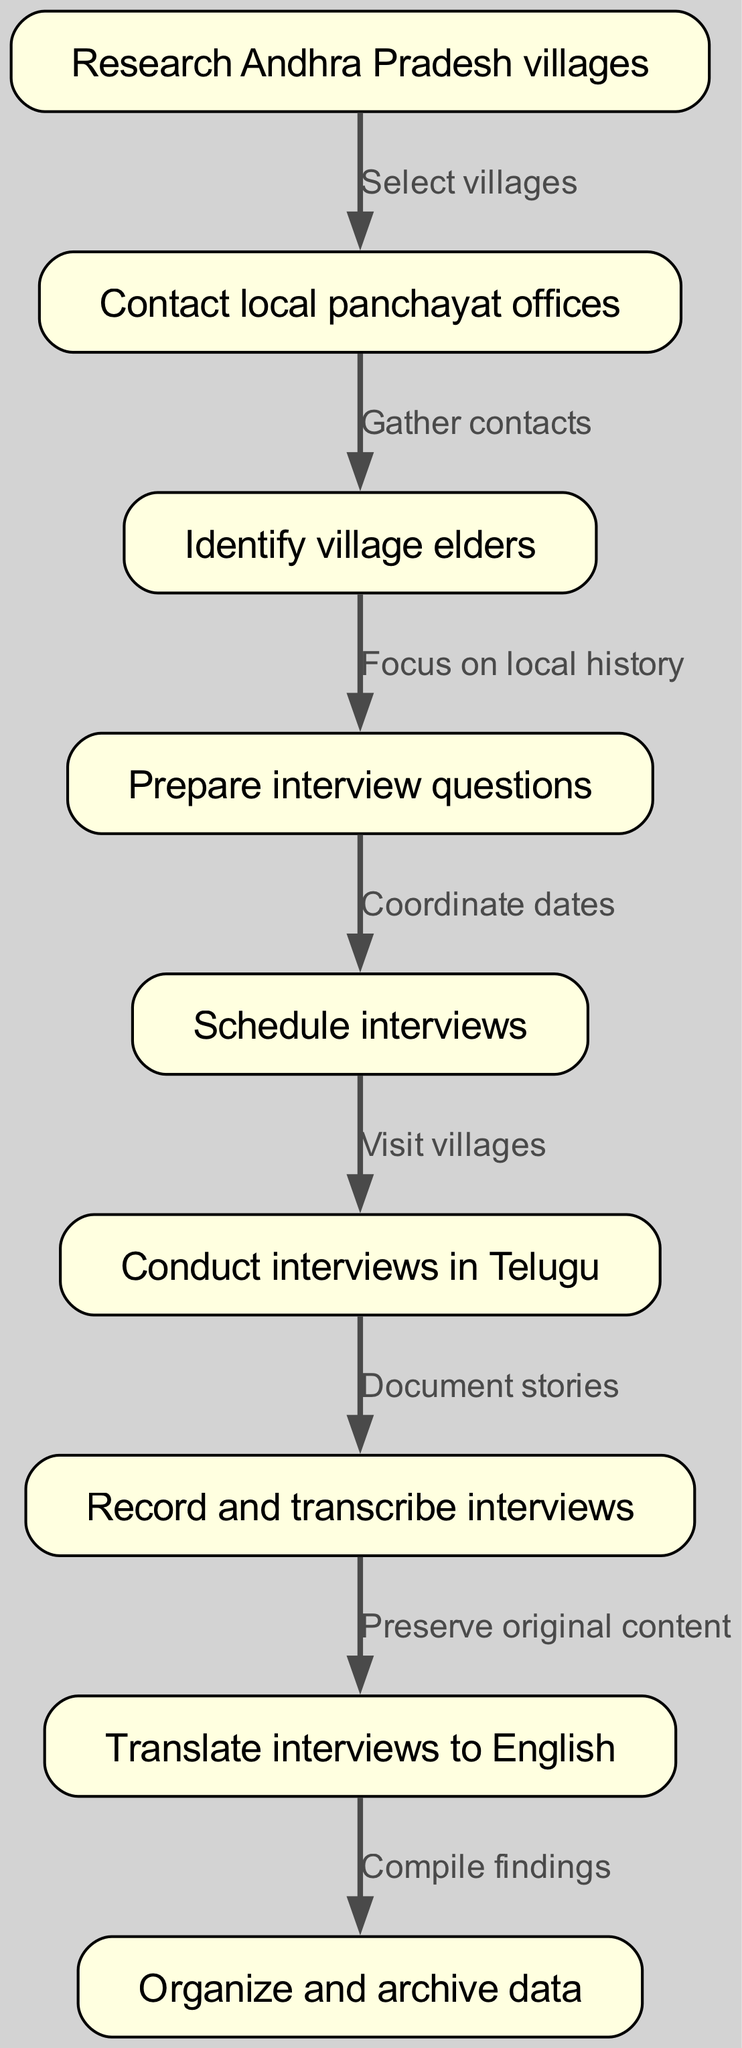What is the first step in the workflow? The first step in the workflow is represented by the node labeled "Research Andhra Pradesh villages." It can be found at the top of the diagram as the starting point.
Answer: Research Andhra Pradesh villages How many nodes are there in total? By counting each individual box or node in the flowchart, we find that there are nine distinct nodes listed.
Answer: 9 What action follows contacting local panchayat offices? The action that follows "Contact local panchayat offices" is "Identify village elders," shown as the next node in the flowchart.
Answer: Identify village elders What do you do after preparing interview questions? Once you have "Prepared interview questions," the next action is to "Schedule interviews," indicated by the connecting edge from the fourth node to the fifth node.
Answer: Schedule interviews What is the final task in the workflow? The last task in the workflow is indicated by the final node, which is "Organize and archive data." This is the concluding step where the accumulated information will be processed.
Answer: Organize and archive data Which step involves translating interviews? The step that involves translating interviews is represented by the node labeled "Translate interviews to English." This step comes after the interviews have been recorded and transcribed.
Answer: Translate interviews to English What is the relationship between scheduling interviews and conducting interviews? The relationship is that after "Schedule interviews," the next step is "Conduct interviews in Telugu," showing a direct progression from scheduling to execution.
Answer: Conduct interviews in Telugu How many edges connect the nodes in the workflow? By tallying the lines that connect the nodes, we can determine that there are eight edges present in the diagram that link the steps together.
Answer: 8 What is the focus area for identifying village elders? The focus area for identifying village elders is "local history," as indicated by the connection from "Identify village elders" to "Prepare interview questions."
Answer: local history What must be done before conducting interviews? Before conducting interviews, "Schedule interviews" must be completed, which is the step directly preceding the interview process in the workflow.
Answer: Schedule interviews 